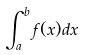<formula> <loc_0><loc_0><loc_500><loc_500>\int _ { a } ^ { b } f ( x ) d x</formula> 